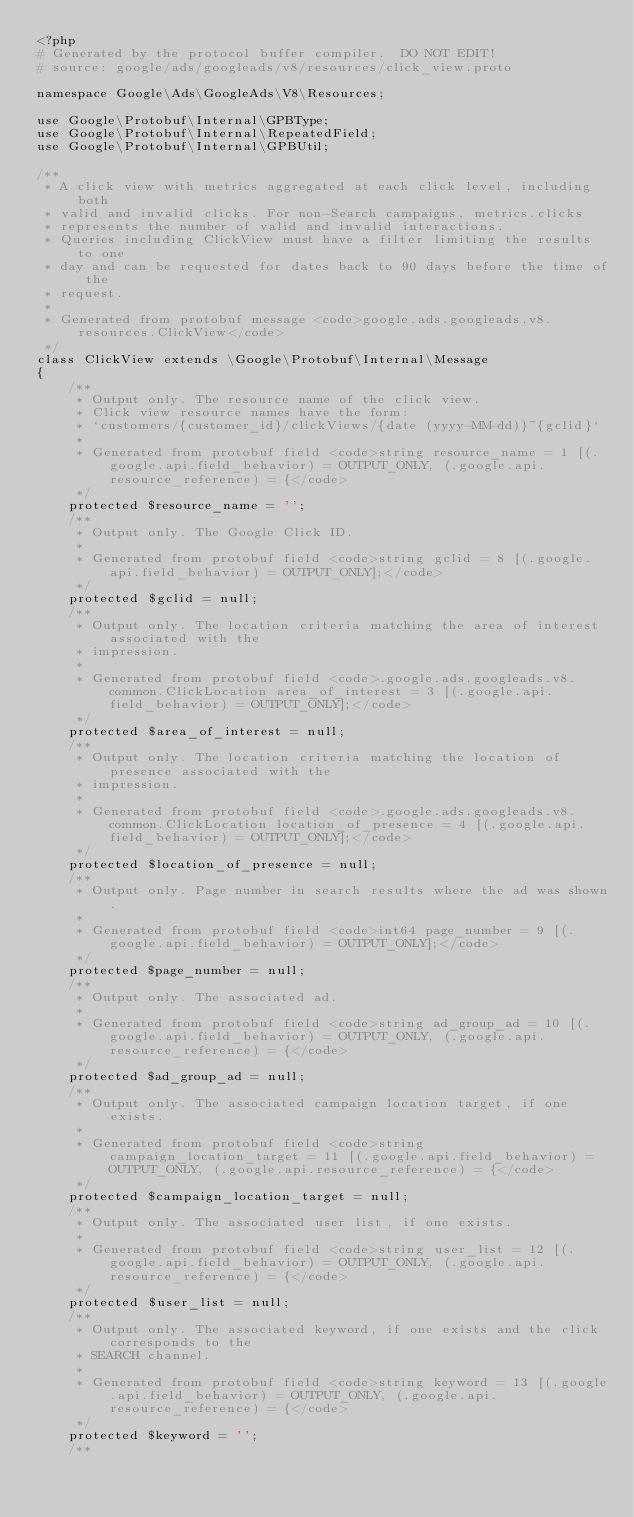Convert code to text. <code><loc_0><loc_0><loc_500><loc_500><_PHP_><?php
# Generated by the protocol buffer compiler.  DO NOT EDIT!
# source: google/ads/googleads/v8/resources/click_view.proto

namespace Google\Ads\GoogleAds\V8\Resources;

use Google\Protobuf\Internal\GPBType;
use Google\Protobuf\Internal\RepeatedField;
use Google\Protobuf\Internal\GPBUtil;

/**
 * A click view with metrics aggregated at each click level, including both
 * valid and invalid clicks. For non-Search campaigns, metrics.clicks
 * represents the number of valid and invalid interactions.
 * Queries including ClickView must have a filter limiting the results to one
 * day and can be requested for dates back to 90 days before the time of the
 * request.
 *
 * Generated from protobuf message <code>google.ads.googleads.v8.resources.ClickView</code>
 */
class ClickView extends \Google\Protobuf\Internal\Message
{
    /**
     * Output only. The resource name of the click view.
     * Click view resource names have the form:
     * `customers/{customer_id}/clickViews/{date (yyyy-MM-dd)}~{gclid}`
     *
     * Generated from protobuf field <code>string resource_name = 1 [(.google.api.field_behavior) = OUTPUT_ONLY, (.google.api.resource_reference) = {</code>
     */
    protected $resource_name = '';
    /**
     * Output only. The Google Click ID.
     *
     * Generated from protobuf field <code>string gclid = 8 [(.google.api.field_behavior) = OUTPUT_ONLY];</code>
     */
    protected $gclid = null;
    /**
     * Output only. The location criteria matching the area of interest associated with the
     * impression.
     *
     * Generated from protobuf field <code>.google.ads.googleads.v8.common.ClickLocation area_of_interest = 3 [(.google.api.field_behavior) = OUTPUT_ONLY];</code>
     */
    protected $area_of_interest = null;
    /**
     * Output only. The location criteria matching the location of presence associated with the
     * impression.
     *
     * Generated from protobuf field <code>.google.ads.googleads.v8.common.ClickLocation location_of_presence = 4 [(.google.api.field_behavior) = OUTPUT_ONLY];</code>
     */
    protected $location_of_presence = null;
    /**
     * Output only. Page number in search results where the ad was shown.
     *
     * Generated from protobuf field <code>int64 page_number = 9 [(.google.api.field_behavior) = OUTPUT_ONLY];</code>
     */
    protected $page_number = null;
    /**
     * Output only. The associated ad.
     *
     * Generated from protobuf field <code>string ad_group_ad = 10 [(.google.api.field_behavior) = OUTPUT_ONLY, (.google.api.resource_reference) = {</code>
     */
    protected $ad_group_ad = null;
    /**
     * Output only. The associated campaign location target, if one exists.
     *
     * Generated from protobuf field <code>string campaign_location_target = 11 [(.google.api.field_behavior) = OUTPUT_ONLY, (.google.api.resource_reference) = {</code>
     */
    protected $campaign_location_target = null;
    /**
     * Output only. The associated user list, if one exists.
     *
     * Generated from protobuf field <code>string user_list = 12 [(.google.api.field_behavior) = OUTPUT_ONLY, (.google.api.resource_reference) = {</code>
     */
    protected $user_list = null;
    /**
     * Output only. The associated keyword, if one exists and the click corresponds to the
     * SEARCH channel.
     *
     * Generated from protobuf field <code>string keyword = 13 [(.google.api.field_behavior) = OUTPUT_ONLY, (.google.api.resource_reference) = {</code>
     */
    protected $keyword = '';
    /**</code> 